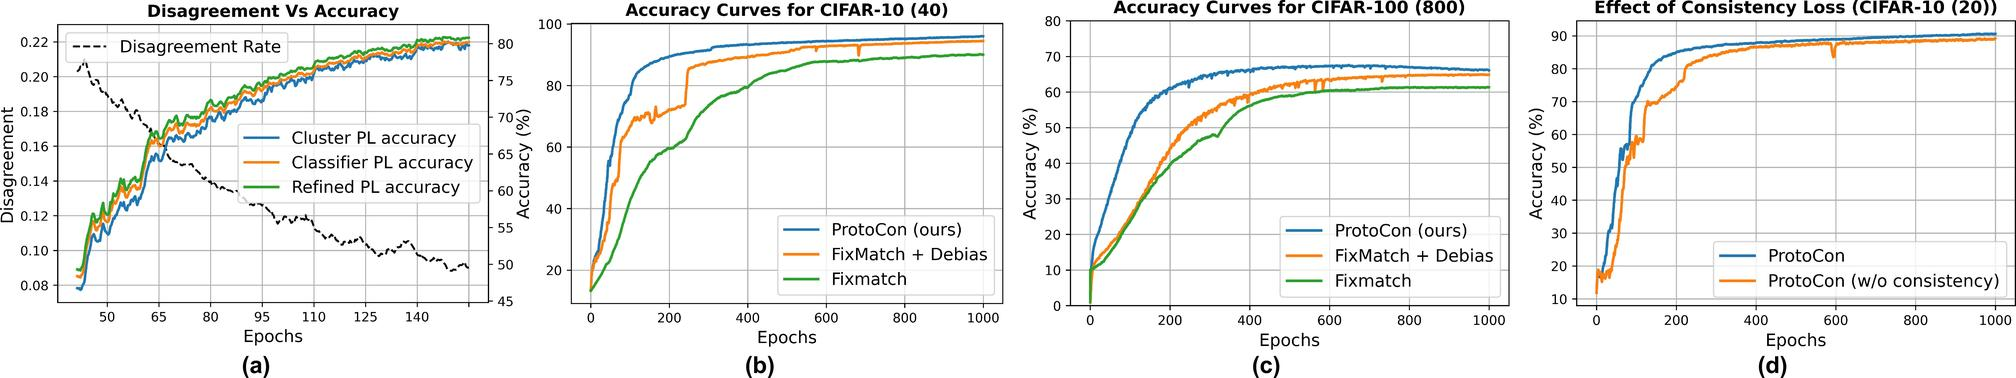What trend is observed in the Disagreement Rate as the number of epochs increases? A) The Disagreement Rate increases. B) The Disagreement Rate decreases. C) The Disagreement Rate remains constant. D) The Disagreement Rate fluctuates without a clear trend. ## Figure (a) The graph in figure (a) clearly shows a downward trend in the Disagreement Rate as the number of epochs increases. This indicates that as the model is trained over more epochs, the consistency between different predictions or models likely improves, demonstrating enhanced agreement over time. Understanding these dynamics can be crucial for optimizing the training process of models to achieve better general accuracy and reliability. Therefore, the correct answer is B) The Disagreement Rate decreases. 